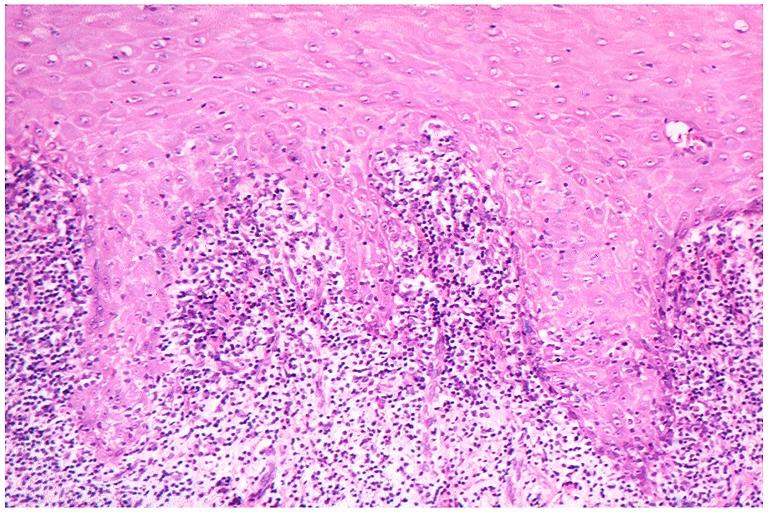does this image show lichen planus?
Answer the question using a single word or phrase. Yes 